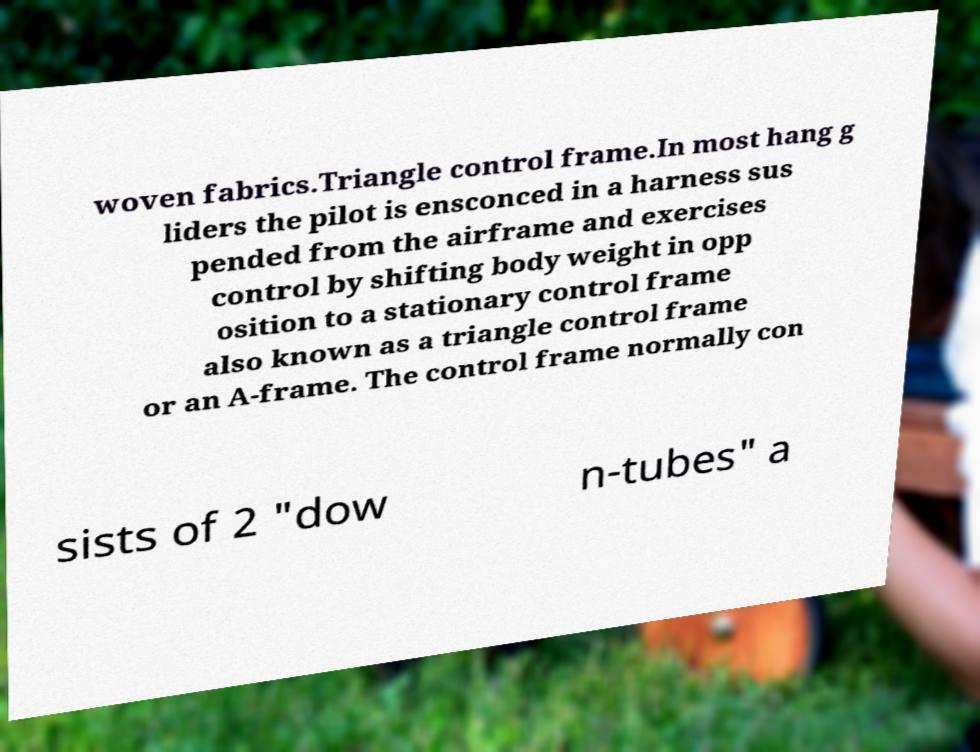I need the written content from this picture converted into text. Can you do that? woven fabrics.Triangle control frame.In most hang g liders the pilot is ensconced in a harness sus pended from the airframe and exercises control by shifting body weight in opp osition to a stationary control frame also known as a triangle control frame or an A-frame. The control frame normally con sists of 2 "dow n-tubes" a 